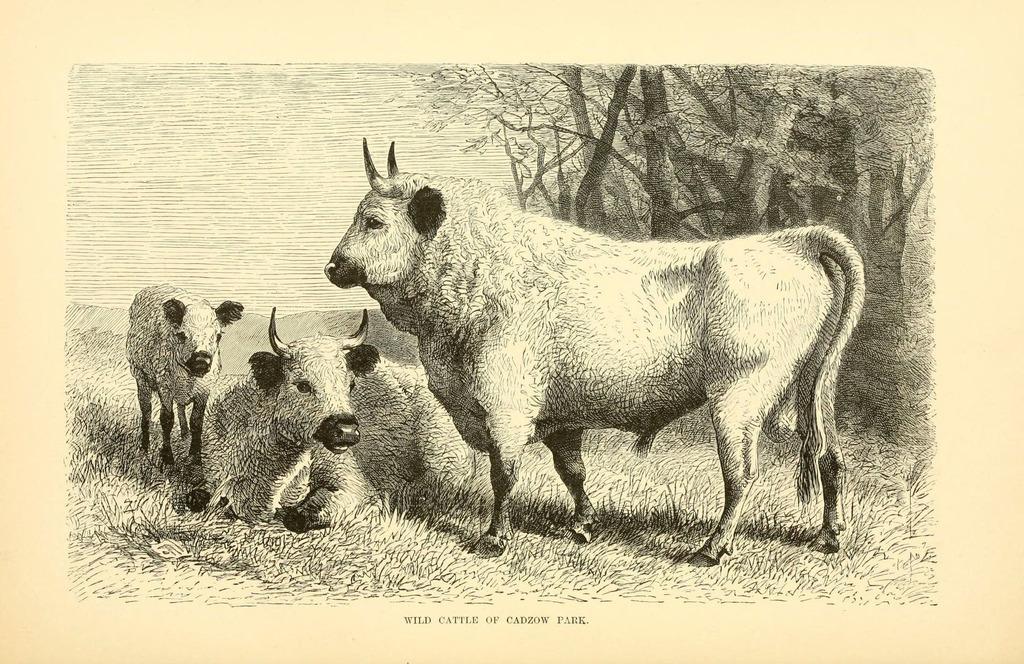How would you summarize this image in a sentence or two? In this picture, it seems like a poster where we can see animals, trees and water. 